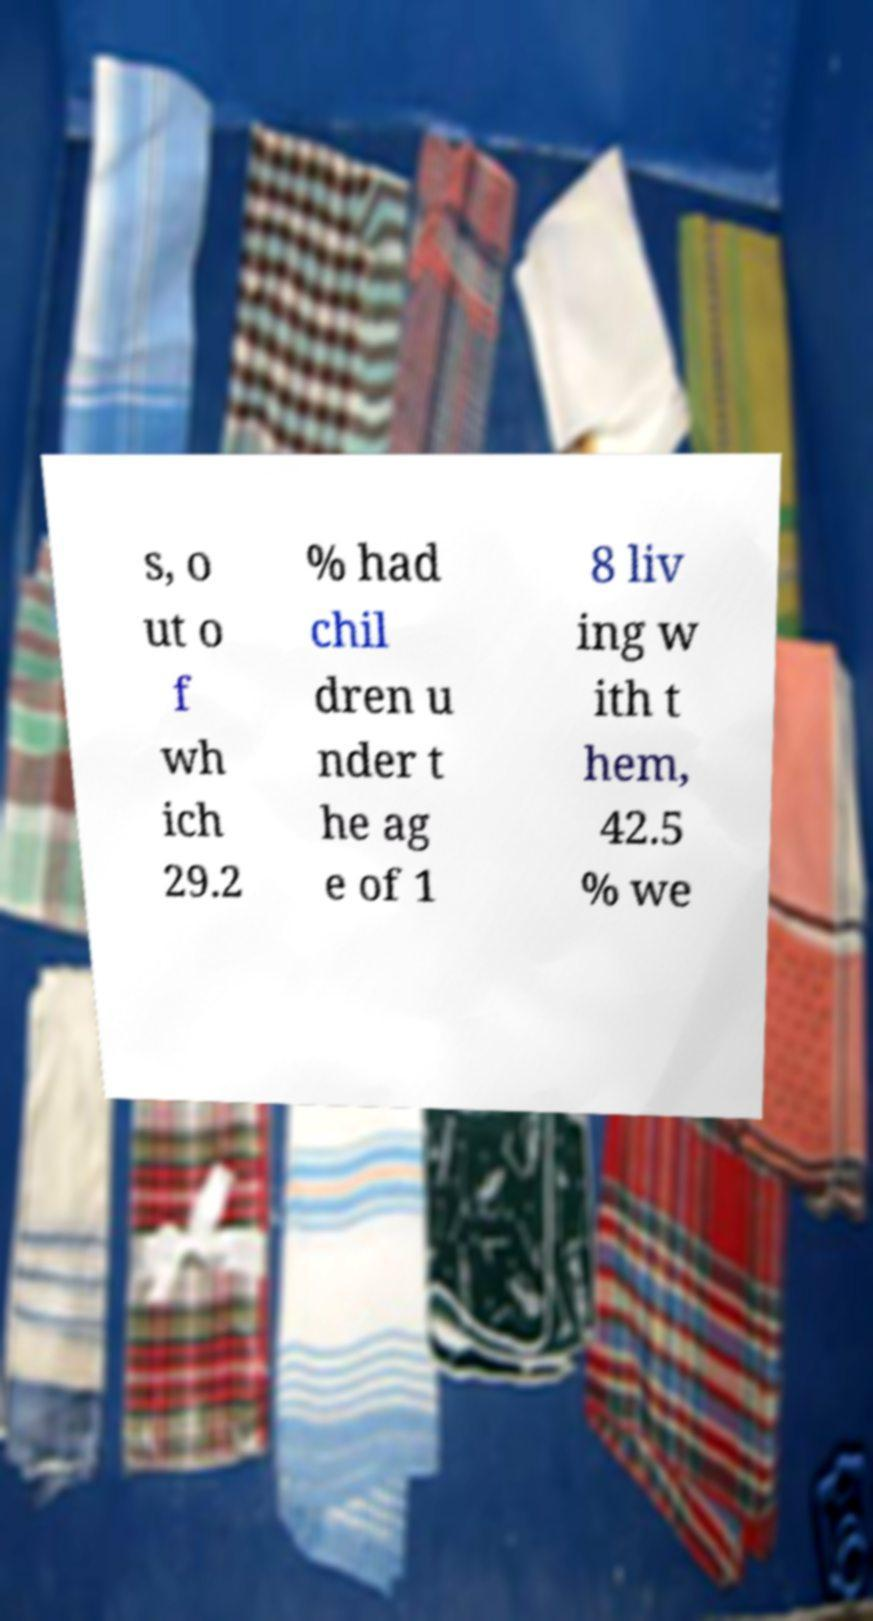There's text embedded in this image that I need extracted. Can you transcribe it verbatim? s, o ut o f wh ich 29.2 % had chil dren u nder t he ag e of 1 8 liv ing w ith t hem, 42.5 % we 